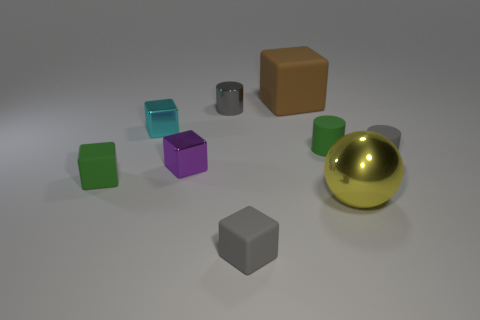What is the size of the other cylinder that is the same color as the metallic cylinder?
Give a very brief answer. Small. There is a brown rubber object that is the same shape as the purple shiny thing; what is its size?
Provide a succinct answer. Large. Are there the same number of big rubber cubes that are left of the green cube and large yellow spheres?
Your response must be concise. No. How many other things are the same color as the large block?
Your answer should be compact. 0. Are there fewer gray metallic cylinders left of the small cyan shiny block than brown rubber blocks?
Your response must be concise. Yes. Are there any gray metallic cylinders that have the same size as the gray rubber cylinder?
Keep it short and to the point. Yes. There is a large rubber cube; is it the same color as the small matte block that is right of the gray metal object?
Keep it short and to the point. No. What number of big brown things are behind the tiny green matte thing in front of the small purple object?
Provide a succinct answer. 1. There is a rubber block that is in front of the big object that is in front of the tiny gray metallic cylinder; what color is it?
Give a very brief answer. Gray. There is a thing that is to the left of the small gray matte cylinder and on the right side of the tiny green cylinder; what material is it?
Give a very brief answer. Metal. 